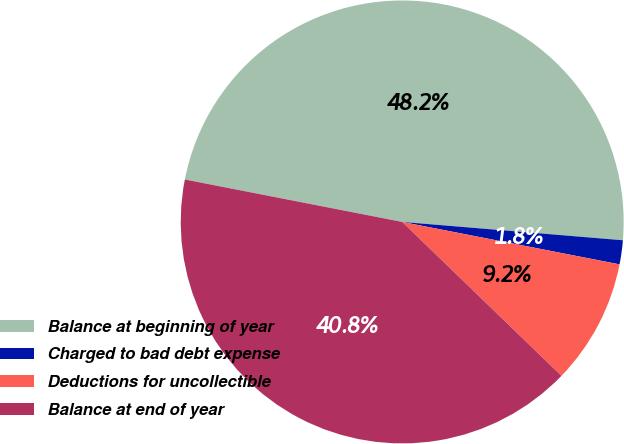Convert chart. <chart><loc_0><loc_0><loc_500><loc_500><pie_chart><fcel>Balance at beginning of year<fcel>Charged to bad debt expense<fcel>Deductions for uncollectible<fcel>Balance at end of year<nl><fcel>48.25%<fcel>1.75%<fcel>9.16%<fcel>40.84%<nl></chart> 